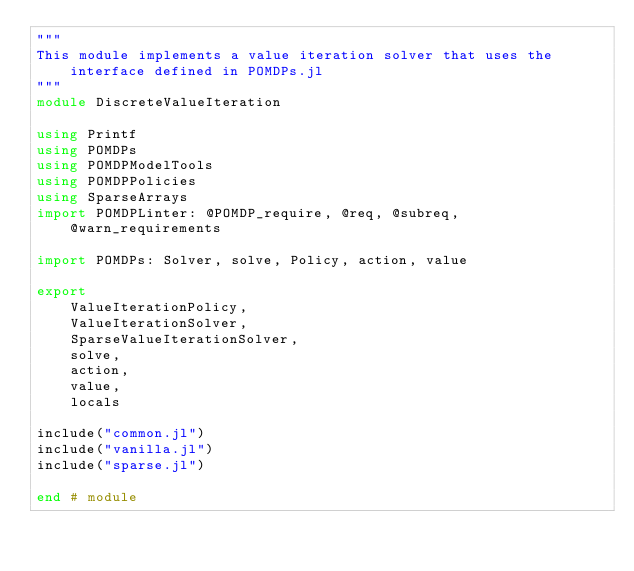Convert code to text. <code><loc_0><loc_0><loc_500><loc_500><_Julia_>"""
This module implements a value iteration solver that uses the interface defined in POMDPs.jl
"""
module DiscreteValueIteration

using Printf
using POMDPs
using POMDPModelTools
using POMDPPolicies
using SparseArrays
import POMDPLinter: @POMDP_require, @req, @subreq, @warn_requirements

import POMDPs: Solver, solve, Policy, action, value 

export
    ValueIterationPolicy,
    ValueIterationSolver,
    SparseValueIterationSolver,
    solve,
    action,
    value,
    locals

include("common.jl")
include("vanilla.jl")
include("sparse.jl")

end # module
</code> 